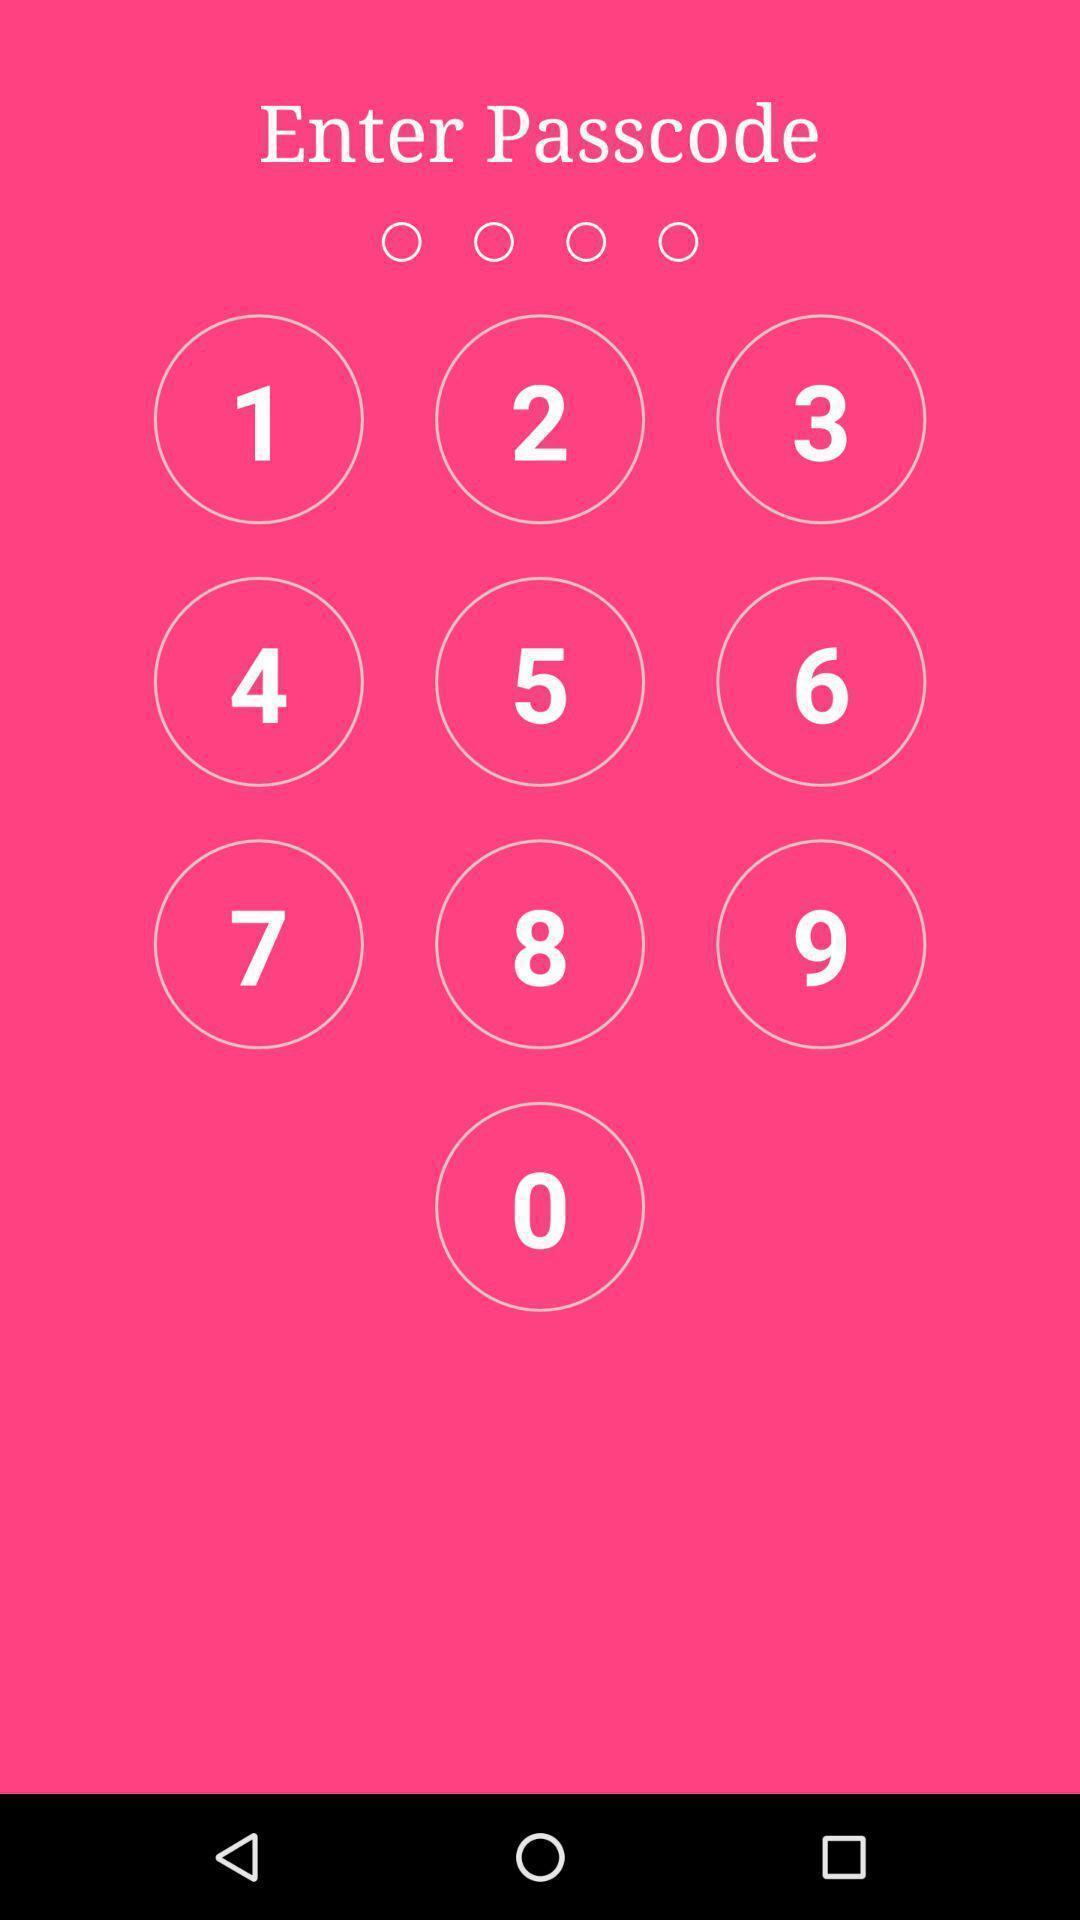What can you discern from this picture? Page displaying keypad to enter passcode. 